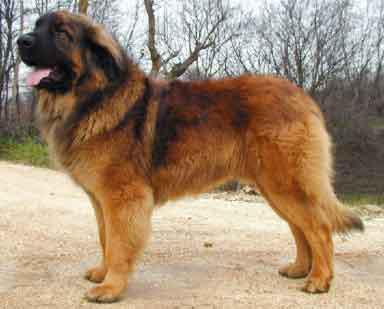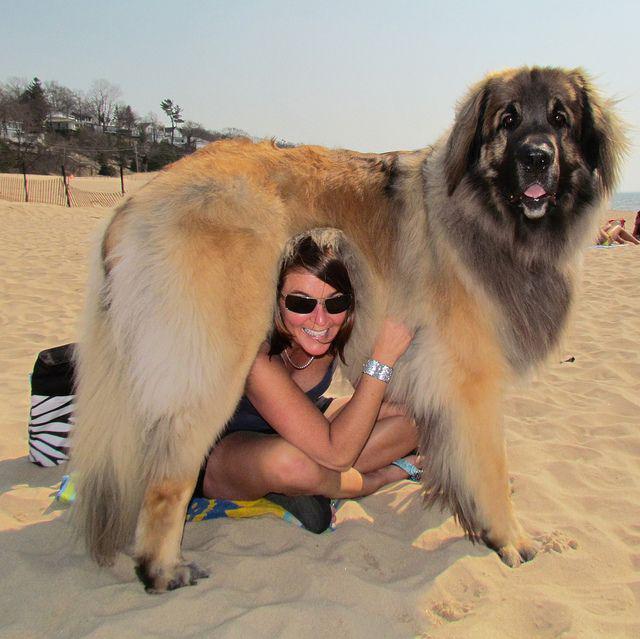The first image is the image on the left, the second image is the image on the right. Given the left and right images, does the statement "A person is posed with one big dog that is standing with its body turned rightward." hold true? Answer yes or no. Yes. The first image is the image on the left, the second image is the image on the right. For the images displayed, is the sentence "A large dog is standing outdoors next to a human." factually correct? Answer yes or no. Yes. 